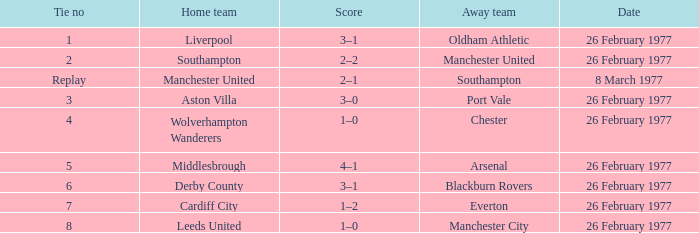Write the full table. {'header': ['Tie no', 'Home team', 'Score', 'Away team', 'Date'], 'rows': [['1', 'Liverpool', '3–1', 'Oldham Athletic', '26 February 1977'], ['2', 'Southampton', '2–2', 'Manchester United', '26 February 1977'], ['Replay', 'Manchester United', '2–1', 'Southampton', '8 March 1977'], ['3', 'Aston Villa', '3–0', 'Port Vale', '26 February 1977'], ['4', 'Wolverhampton Wanderers', '1–0', 'Chester', '26 February 1977'], ['5', 'Middlesbrough', '4–1', 'Arsenal', '26 February 1977'], ['6', 'Derby County', '3–1', 'Blackburn Rovers', '26 February 1977'], ['7', 'Cardiff City', '1–2', 'Everton', '26 February 1977'], ['8', 'Leeds United', '1–0', 'Manchester City', '26 February 1977']]} What's the score when the draw number was 6? 3–1. 